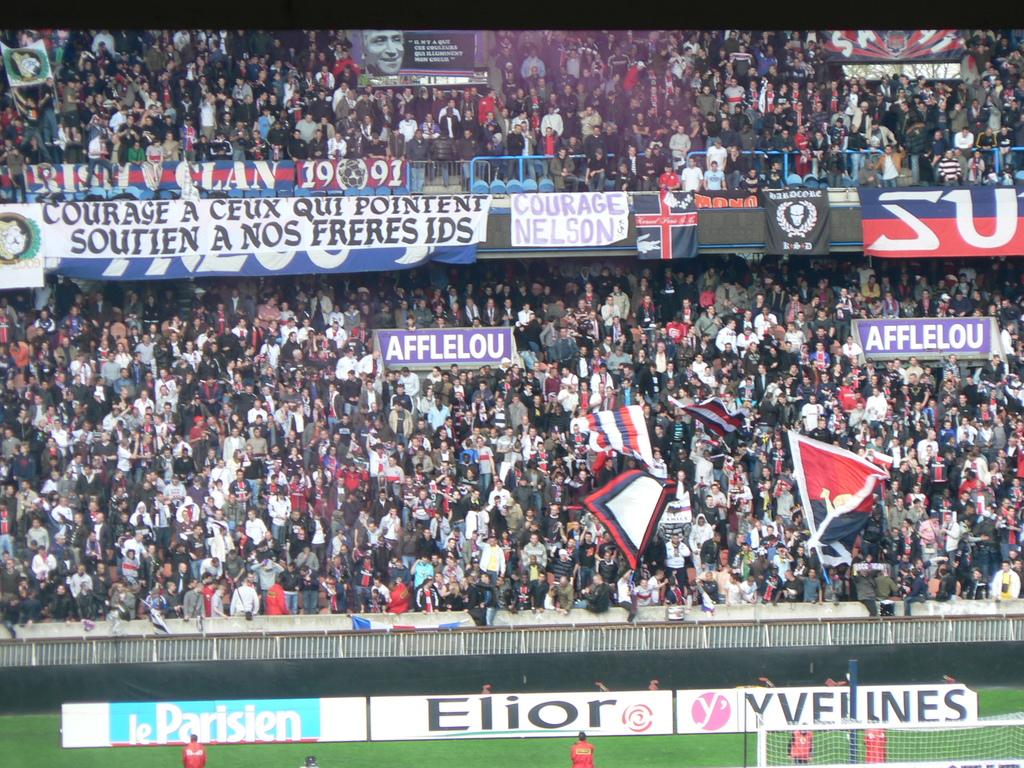What's the name in the middle on the very bottom?
Give a very brief answer. Elior. What two big white letters are on the sign to the far right?
Provide a short and direct response. Su. 